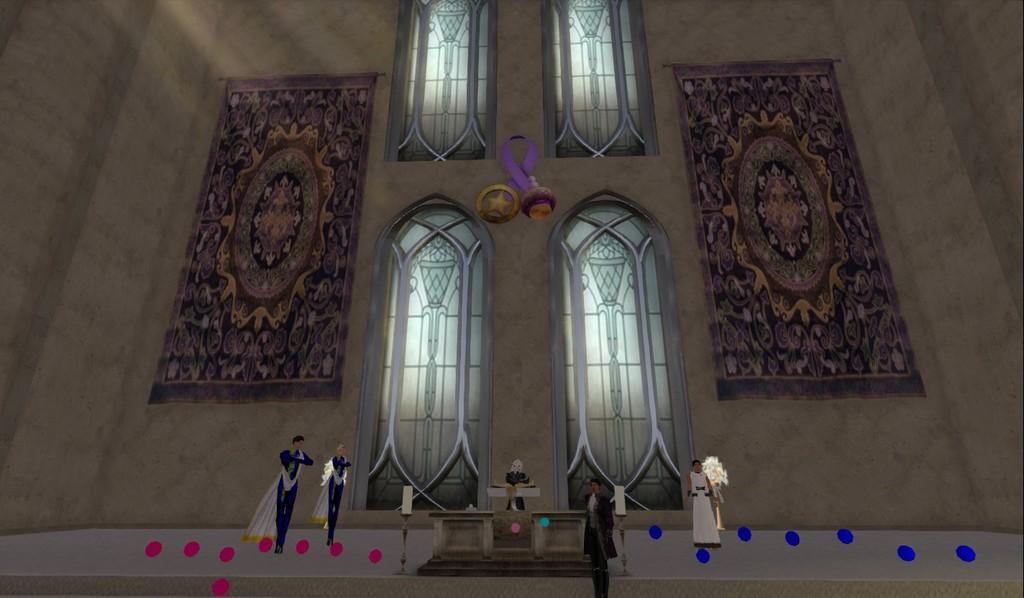Describe this image in one or two sentences. In the foreground I can see five persons statues. In the background I can see windows, stone craft and a wall. This image is taken may be in a church. 